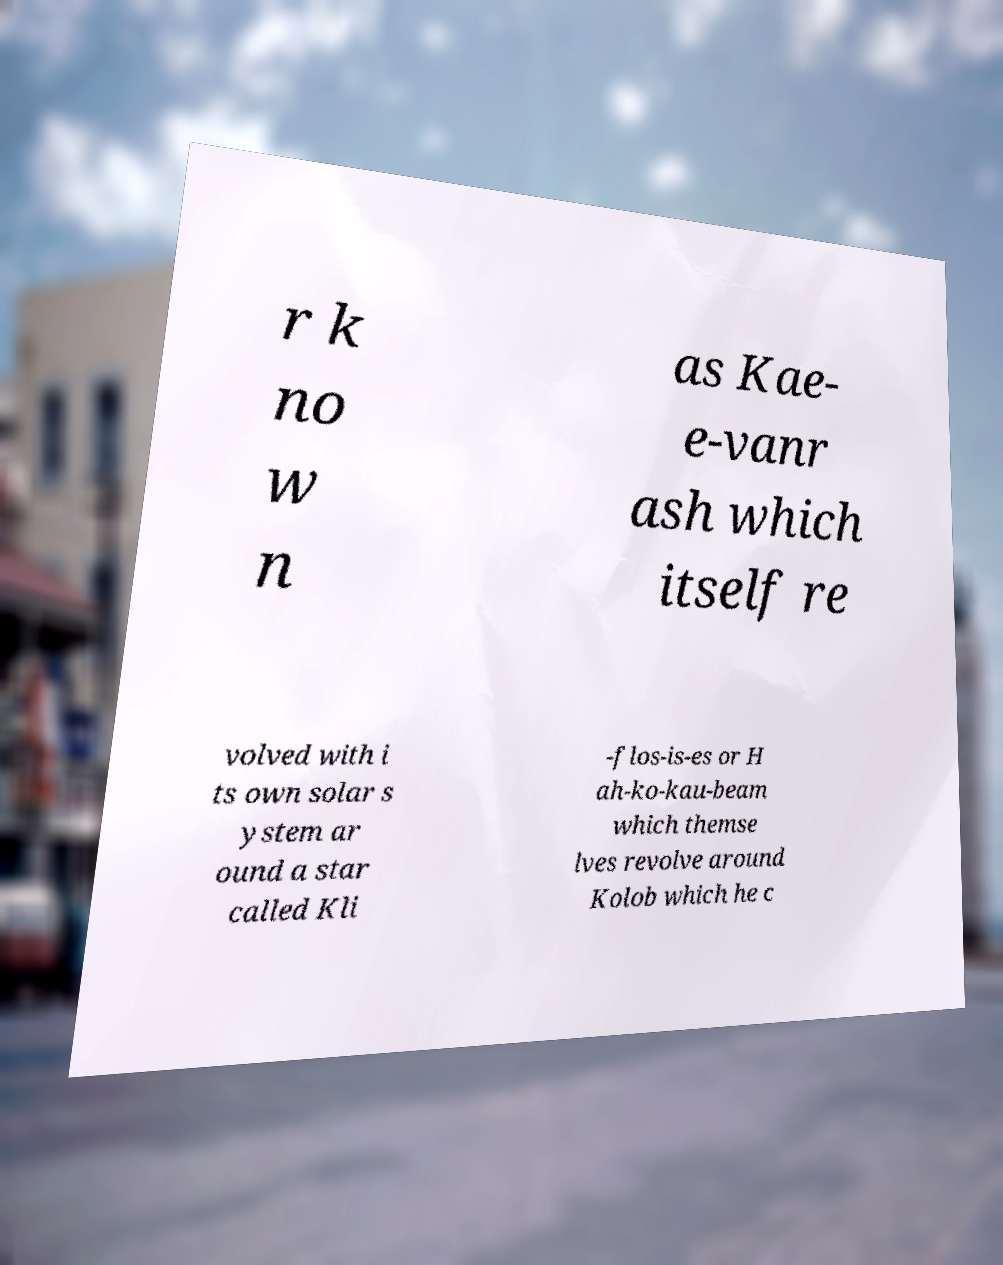Can you accurately transcribe the text from the provided image for me? r k no w n as Kae- e-vanr ash which itself re volved with i ts own solar s ystem ar ound a star called Kli -flos-is-es or H ah-ko-kau-beam which themse lves revolve around Kolob which he c 